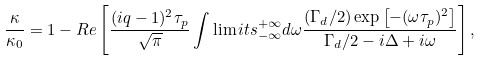<formula> <loc_0><loc_0><loc_500><loc_500>\frac { \kappa } { \kappa _ { 0 } } = 1 - R e \left [ \frac { ( i q - 1 ) ^ { 2 } \tau _ { p } } { \sqrt { \pi } } \int \lim i t s _ { - \infty } ^ { + \infty } d \omega \frac { ( \Gamma _ { d } / 2 ) \exp \left [ - ( \omega \tau _ { p } ) ^ { 2 } \right ] } { \Gamma _ { d } / 2 - i \Delta + i \omega } \right ] ,</formula> 